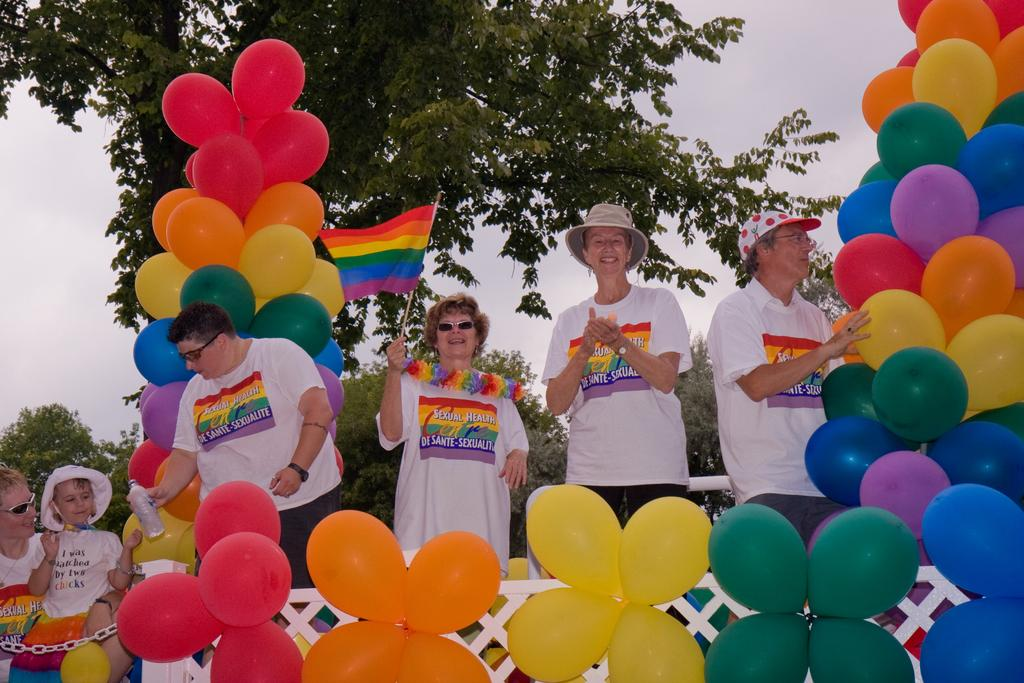What is the main feature in the foreground of the image? There are many balloons in the foreground of the image. What can be seen in the background of the image? People are standing in the background of the image. Where is the tree located in the image? There is a tree on the left side of the image. What is visible in the background of the image besides the people? The sky is visible in the background of the image. How many books are stacked on the tree in the image? There are no books present in the image, and the tree is not being used as a bookshelf. 